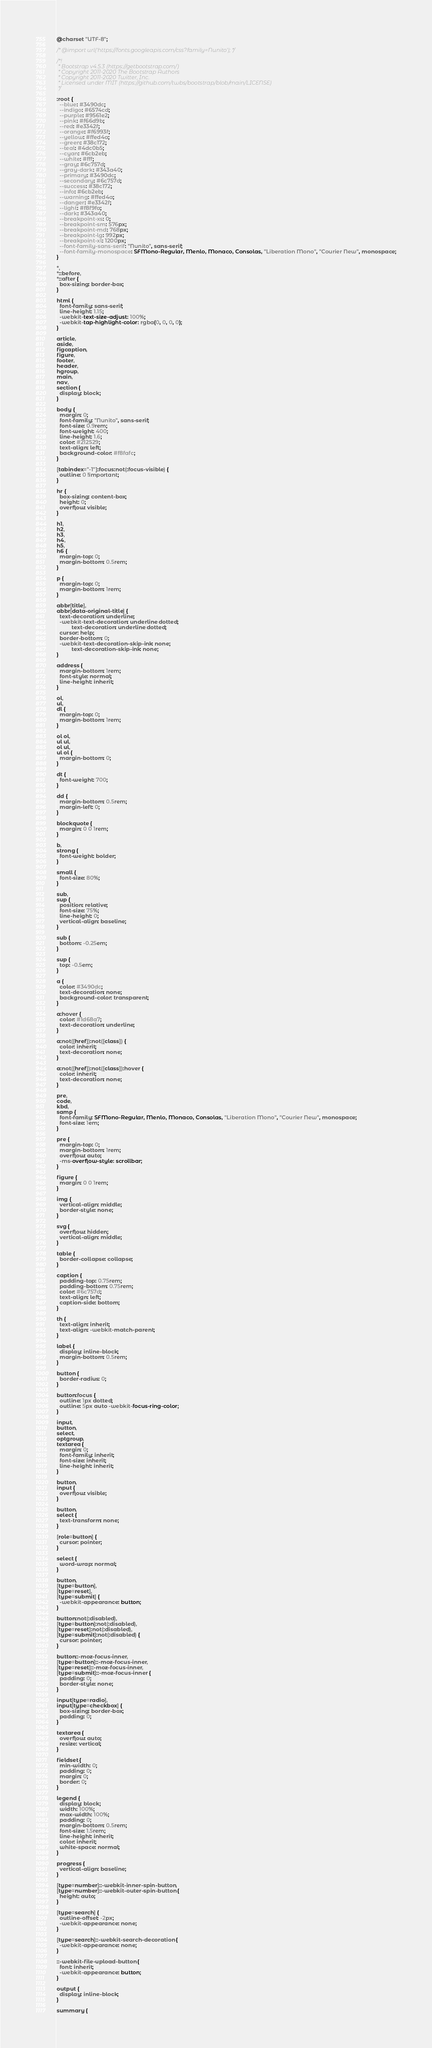Convert code to text. <code><loc_0><loc_0><loc_500><loc_500><_CSS_>@charset "UTF-8";

/* @import url('https://fonts.googleapis.com/css?family=Nunito'); */

/*!
 * Bootstrap v4.5.3 (https://getbootstrap.com/)
 * Copyright 2011-2020 The Bootstrap Authors
 * Copyright 2011-2020 Twitter, Inc.
 * Licensed under MIT (https://github.com/twbs/bootstrap/blob/main/LICENSE)
 */

:root {
  --blue: #3490dc;
  --indigo: #6574cd;
  --purple: #9561e2;
  --pink: #f66d9b;
  --red: #e3342f;
  --orange: #f6993f;
  --yellow: #ffed4a;
  --green: #38c172;
  --teal: #4dc0b5;
  --cyan: #6cb2eb;
  --white: #fff;
  --gray: #6c757d;
  --gray-dark: #343a40;
  --primary: #3490dc;
  --secondary: #6c757d;
  --success: #38c172;
  --info: #6cb2eb;
  --warning: #ffed4a;
  --danger: #e3342f;
  --light: #f8f9fa;
  --dark: #343a40;
  --breakpoint-xs: 0;
  --breakpoint-sm: 576px;
  --breakpoint-md: 768px;
  --breakpoint-lg: 992px;
  --breakpoint-xl: 1200px;
  --font-family-sans-serif: "Nunito", sans-serif;
  --font-family-monospace: SFMono-Regular, Menlo, Monaco, Consolas, "Liberation Mono", "Courier New", monospace;
}

*,
*::before,
*::after {
  box-sizing: border-box;
}

html {
  font-family: sans-serif;
  line-height: 1.15;
  -webkit-text-size-adjust: 100%;
  -webkit-tap-highlight-color: rgba(0, 0, 0, 0);
}

article,
aside,
figcaption,
figure,
footer,
header,
hgroup,
main,
nav,
section {
  display: block;
}

body {
  margin: 0;
  font-family: "Nunito", sans-serif;
  font-size: 0.9rem;
  font-weight: 400;
  line-height: 1.6;
  color: #212529;
  text-align: left;
  background-color: #f8fafc;
}

[tabindex="-1"]:focus:not(:focus-visible) {
  outline: 0 !important;
}

hr {
  box-sizing: content-box;
  height: 0;
  overflow: visible;
}

h1,
h2,
h3,
h4,
h5,
h6 {
  margin-top: 0;
  margin-bottom: 0.5rem;
}

p {
  margin-top: 0;
  margin-bottom: 1rem;
}

abbr[title],
abbr[data-original-title] {
  text-decoration: underline;
  -webkit-text-decoration: underline dotted;
          text-decoration: underline dotted;
  cursor: help;
  border-bottom: 0;
  -webkit-text-decoration-skip-ink: none;
          text-decoration-skip-ink: none;
}

address {
  margin-bottom: 1rem;
  font-style: normal;
  line-height: inherit;
}

ol,
ul,
dl {
  margin-top: 0;
  margin-bottom: 1rem;
}

ol ol,
ul ul,
ol ul,
ul ol {
  margin-bottom: 0;
}

dt {
  font-weight: 700;
}

dd {
  margin-bottom: 0.5rem;
  margin-left: 0;
}

blockquote {
  margin: 0 0 1rem;
}

b,
strong {
  font-weight: bolder;
}

small {
  font-size: 80%;
}

sub,
sup {
  position: relative;
  font-size: 75%;
  line-height: 0;
  vertical-align: baseline;
}

sub {
  bottom: -0.25em;
}

sup {
  top: -0.5em;
}

a {
  color: #3490dc;
  text-decoration: none;
  background-color: transparent;
}

a:hover {
  color: #1d68a7;
  text-decoration: underline;
}

a:not([href]):not([class]) {
  color: inherit;
  text-decoration: none;
}

a:not([href]):not([class]):hover {
  color: inherit;
  text-decoration: none;
}

pre,
code,
kbd,
samp {
  font-family: SFMono-Regular, Menlo, Monaco, Consolas, "Liberation Mono", "Courier New", monospace;
  font-size: 1em;
}

pre {
  margin-top: 0;
  margin-bottom: 1rem;
  overflow: auto;
  -ms-overflow-style: scrollbar;
}

figure {
  margin: 0 0 1rem;
}

img {
  vertical-align: middle;
  border-style: none;
}

svg {
  overflow: hidden;
  vertical-align: middle;
}

table {
  border-collapse: collapse;
}

caption {
  padding-top: 0.75rem;
  padding-bottom: 0.75rem;
  color: #6c757d;
  text-align: left;
  caption-side: bottom;
}

th {
  text-align: inherit;
  text-align: -webkit-match-parent;
}

label {
  display: inline-block;
  margin-bottom: 0.5rem;
}

button {
  border-radius: 0;
}

button:focus {
  outline: 1px dotted;
  outline: 5px auto -webkit-focus-ring-color;
}

input,
button,
select,
optgroup,
textarea {
  margin: 0;
  font-family: inherit;
  font-size: inherit;
  line-height: inherit;
}

button,
input {
  overflow: visible;
}

button,
select {
  text-transform: none;
}

[role=button] {
  cursor: pointer;
}

select {
  word-wrap: normal;
}

button,
[type=button],
[type=reset],
[type=submit] {
  -webkit-appearance: button;
}

button:not(:disabled),
[type=button]:not(:disabled),
[type=reset]:not(:disabled),
[type=submit]:not(:disabled) {
  cursor: pointer;
}

button::-moz-focus-inner,
[type=button]::-moz-focus-inner,
[type=reset]::-moz-focus-inner,
[type=submit]::-moz-focus-inner {
  padding: 0;
  border-style: none;
}

input[type=radio],
input[type=checkbox] {
  box-sizing: border-box;
  padding: 0;
}

textarea {
  overflow: auto;
  resize: vertical;
}

fieldset {
  min-width: 0;
  padding: 0;
  margin: 0;
  border: 0;
}

legend {
  display: block;
  width: 100%;
  max-width: 100%;
  padding: 0;
  margin-bottom: 0.5rem;
  font-size: 1.5rem;
  line-height: inherit;
  color: inherit;
  white-space: normal;
}

progress {
  vertical-align: baseline;
}

[type=number]::-webkit-inner-spin-button,
[type=number]::-webkit-outer-spin-button {
  height: auto;
}

[type=search] {
  outline-offset: -2px;
  -webkit-appearance: none;
}

[type=search]::-webkit-search-decoration {
  -webkit-appearance: none;
}

::-webkit-file-upload-button {
  font: inherit;
  -webkit-appearance: button;
}

output {
  display: inline-block;
}

summary {</code> 